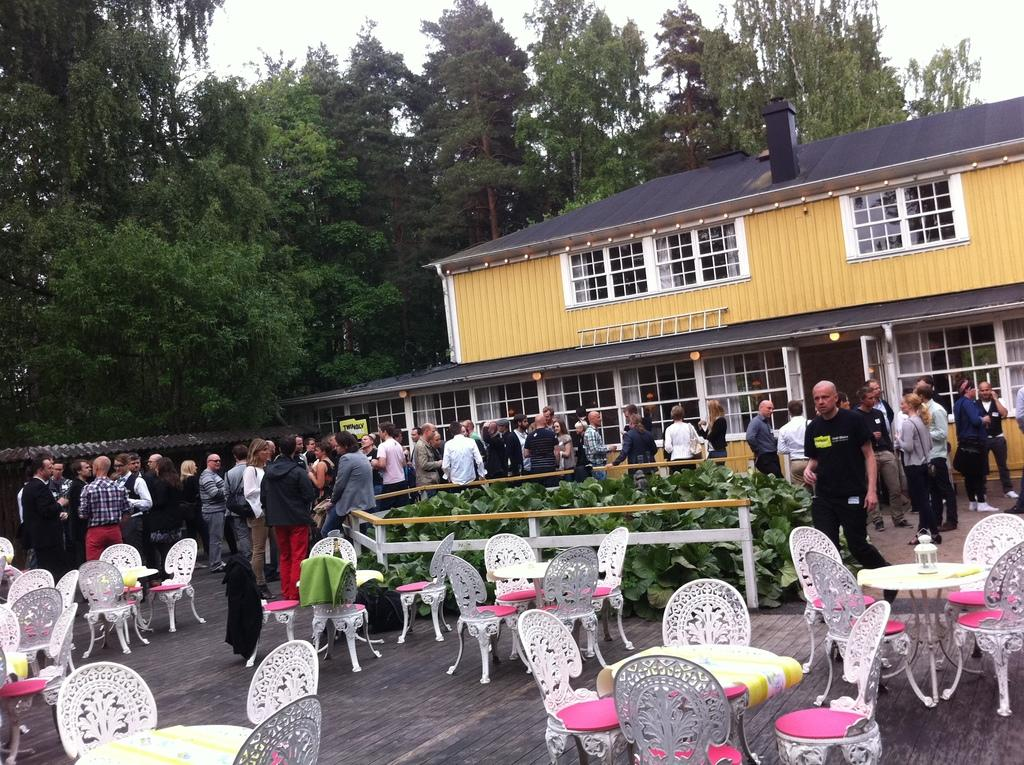How many people are in the image? There is a group of people in the image. What are the people doing in the image? The people are standing. What can be seen in the background of the image? There is a building and trees in the background of the image. What type of furniture is present in the image? There are tables and chairs in the image. What type of lettuce is being served on the beds in the image? There are no beds or lettuce present in the image. How many clams are visible on the tables in the image? There are no clams visible on the tables in the image. 